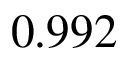<formula> <loc_0><loc_0><loc_500><loc_500>0 . 9 9 2</formula> 